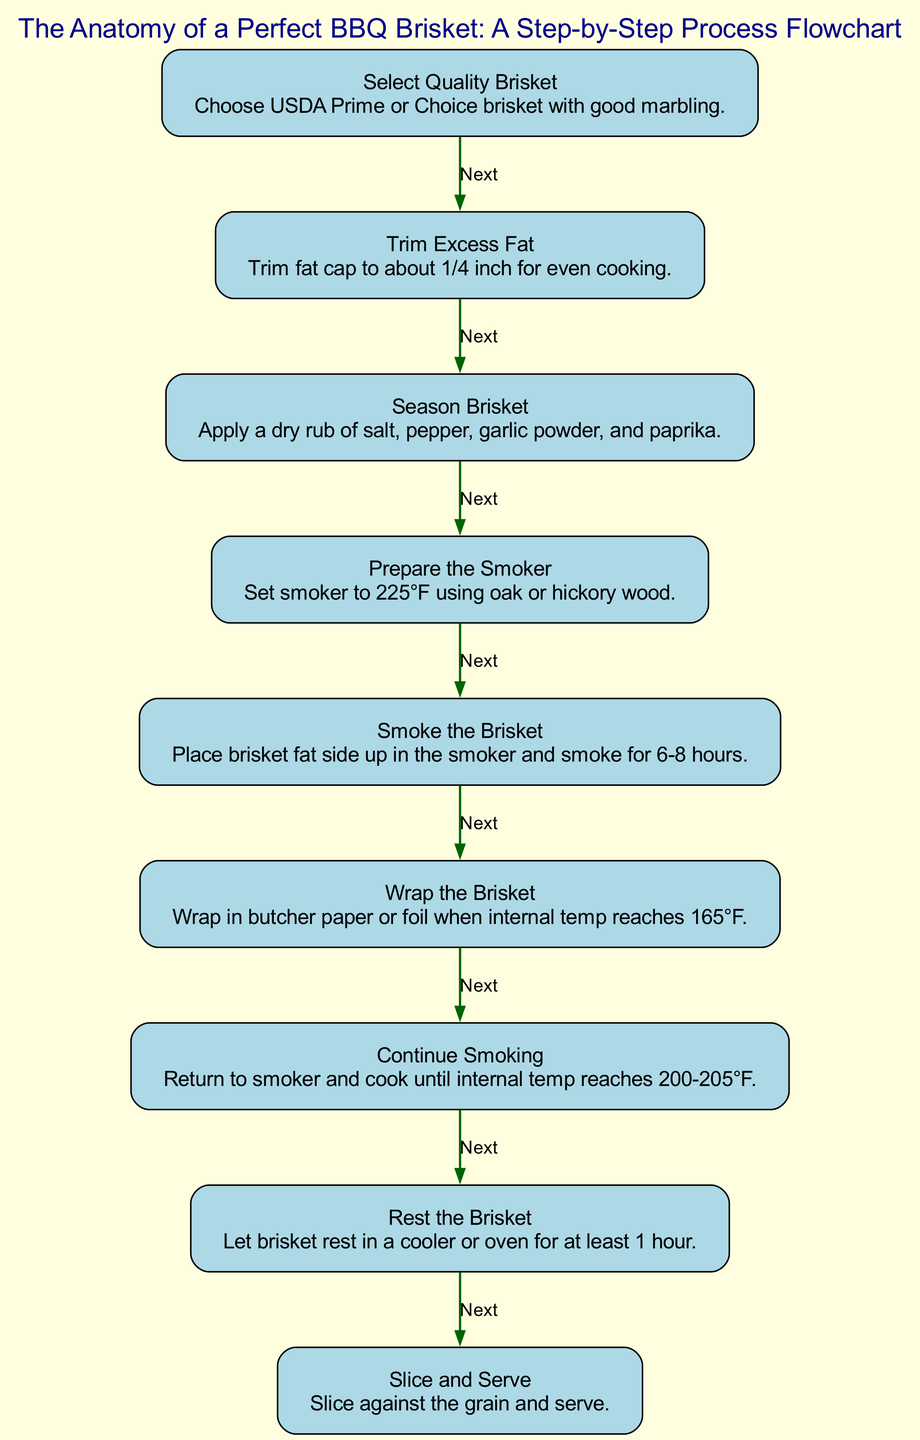What is the first step in the process? The first node in the diagram is "Select Quality Brisket," which is the starting point of the process flow.
Answer: Select Quality Brisket How many total steps are in the process? The diagram includes a list of 9 nodes, each representing a step in the BBQ brisket process. Counting them gives us a total of 9 steps.
Answer: 9 What temperature should the smoker be set to? The step for "Prepare the Smoker" specifies that the smoker should be set to 225°F. This temperature is crucial for the smoking process to be effective.
Answer: 225°F What is done when the internal temperature reaches 165°F? At the step labeled "Wrap the Brisket," it states that when the internal temperature reaches 165°F, you should wrap the brisket in butcher paper or foil.
Answer: Wrap in butcher paper or foil What is the last step before slicing and serving the brisket? The final step before slicing is "Rest the Brisket," which indicates allowing the brisket to rest for at least 1 hour. This resting period is essential for the meat to retain juices.
Answer: Rest the Brisket What type of wood should be used for smoking? In the "Prepare the Smoker" step, it mentions the use of oak or hickory wood, suggesting these types contribute specific flavors to the brisket during the smoking process.
Answer: Oak or hickory wood What is the internal temperature range for finishing cooking the brisket? The step "Continue Smoking" indicates that the brisket should be cooked until the internal temperature reaches between 200°F and 205°F. This range is ideal for perfect tenderness.
Answer: 200-205°F Which step follows after trimming excess fat? The step directly following "Trim Excess Fat" is "Season Brisket," indicating that once the fat is trimmed, the next action is to apply seasoning.
Answer: Season Brisket 